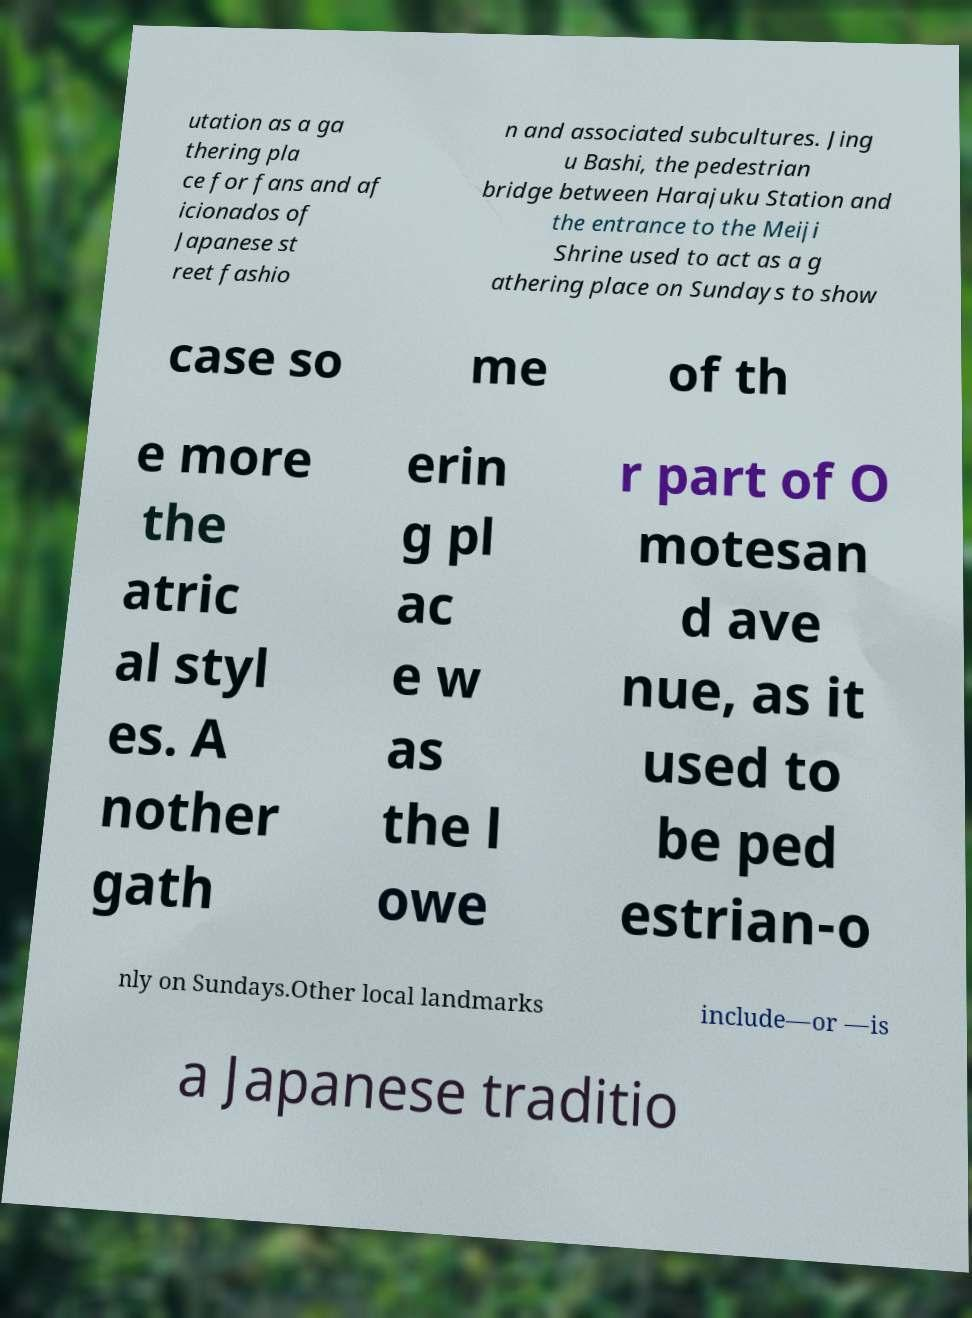Could you assist in decoding the text presented in this image and type it out clearly? utation as a ga thering pla ce for fans and af icionados of Japanese st reet fashio n and associated subcultures. Jing u Bashi, the pedestrian bridge between Harajuku Station and the entrance to the Meiji Shrine used to act as a g athering place on Sundays to show case so me of th e more the atric al styl es. A nother gath erin g pl ac e w as the l owe r part of O motesan d ave nue, as it used to be ped estrian-o nly on Sundays.Other local landmarks include—or —is a Japanese traditio 